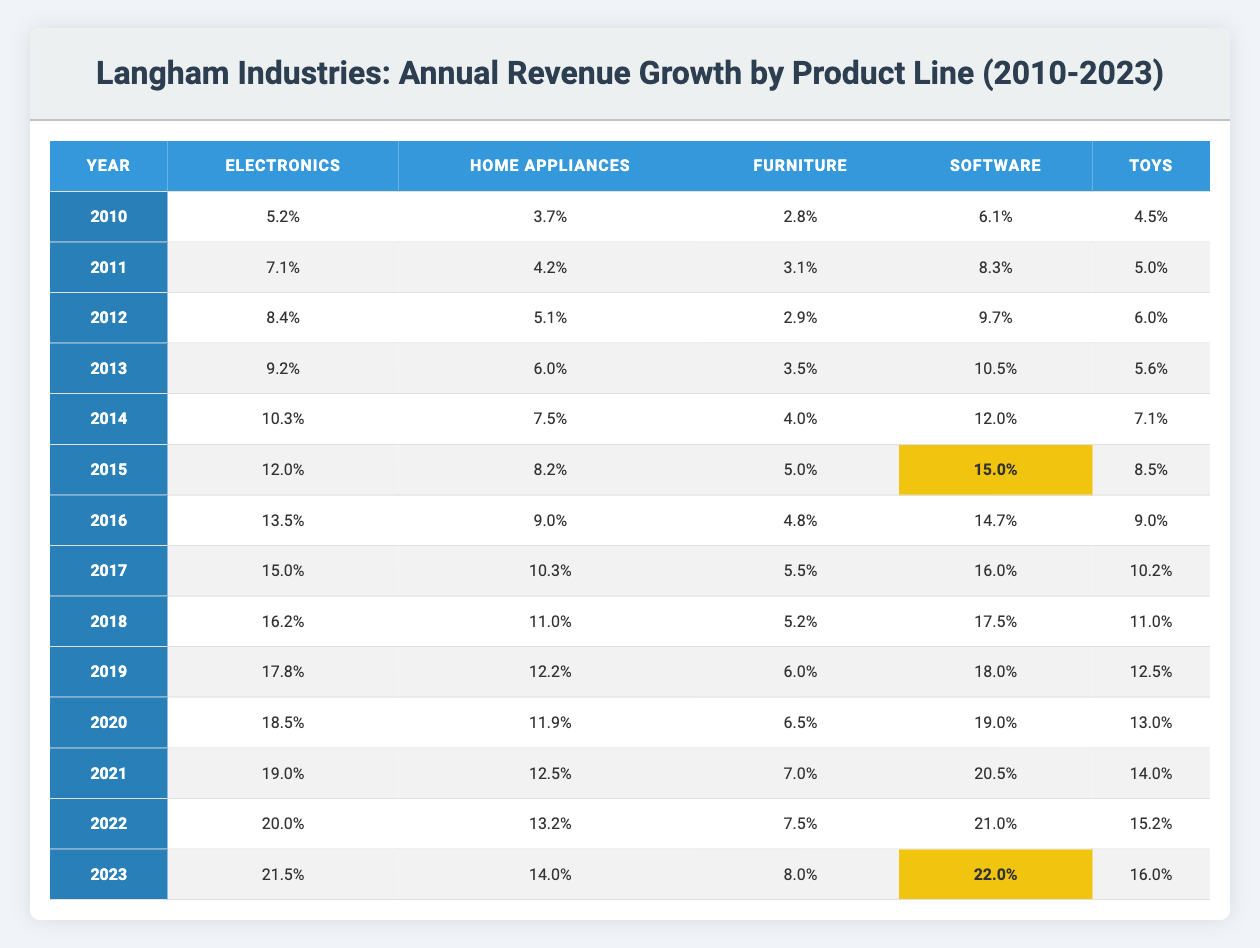What's the revenue growth percentage for Electronics in 2015? Referring to the table, under the year 2015, the revenue growth percentage for Electronics is indicated as 12.0%.
Answer: 12.0% Which product line had the highest growth in 2023? In the year 2023, examining the table, Software shows the highest growth percentage at 22.0%.
Answer: Software What is the average annual revenue growth for Home Appliances from 2010 to 2023? To calculate the average, sum the Home Appliances growth percentages from 2010 to 2023: 3.7 + 4.2 + 5.1 + 6.0 + 7.5 + 8.2 + 9.0 + 10.3 + 11.0 + 12.2 + 11.9 + 12.5 + 13.2 + 14.0 = 144.7. Then, divide by 14 (the number of years): 144.7 / 14 = 10.35.
Answer: 10.35 Has the Furniture product line shown a consistent growth rate over the years? By evaluating the table, the Furniture product line's growth rates from 2010 to 2023 are: 2.8, 3.1, 2.9, 3.5, 4.0, 5.0, 4.8, 5.5, 5.2, 6.0, 6.5, 7.0, 7.5, 8.0. The growth was not consistent as it fluctuated before ultimately increasing in the later years.
Answer: No What was the percentage increase in revenue growth for Toys from 2010 to 2023? From the table, Toys had a growth of 4.5% in 2010 and 16.0% in 2023. The increase is calculated as 16.0 - 4.5 = 11.5%.
Answer: 11.5% 